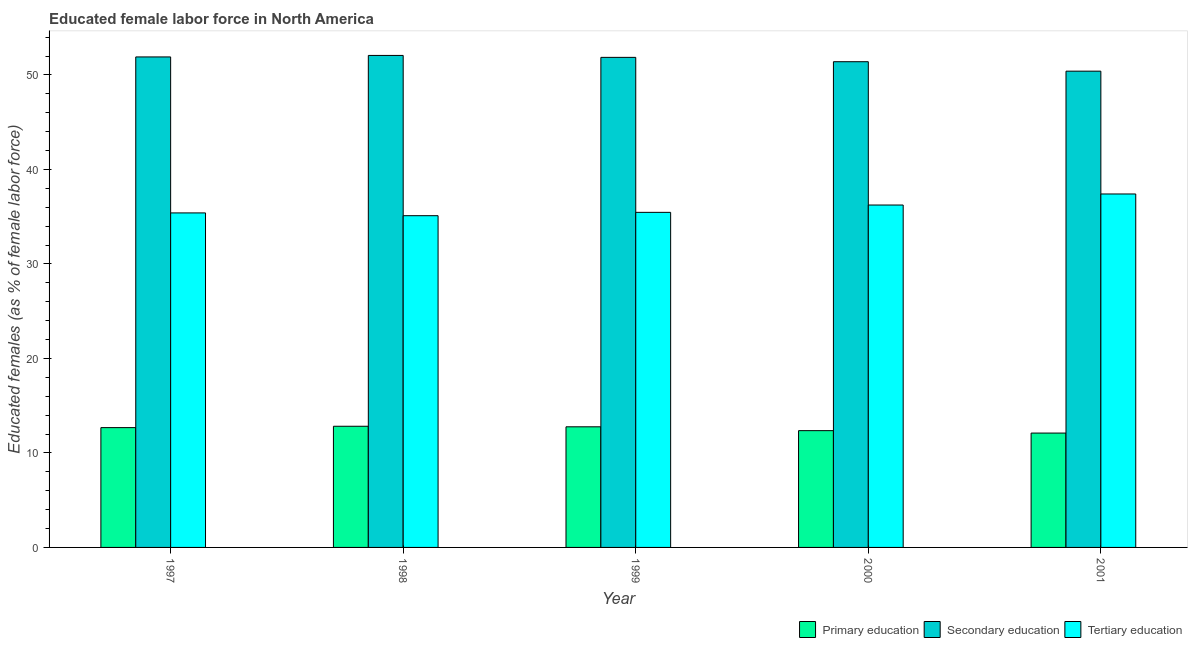Are the number of bars on each tick of the X-axis equal?
Offer a terse response. Yes. How many bars are there on the 4th tick from the left?
Your answer should be very brief. 3. What is the label of the 5th group of bars from the left?
Offer a very short reply. 2001. What is the percentage of female labor force who received primary education in 1998?
Offer a terse response. 12.82. Across all years, what is the maximum percentage of female labor force who received primary education?
Your response must be concise. 12.82. Across all years, what is the minimum percentage of female labor force who received tertiary education?
Your answer should be compact. 35.11. In which year was the percentage of female labor force who received secondary education maximum?
Your answer should be very brief. 1998. What is the total percentage of female labor force who received primary education in the graph?
Ensure brevity in your answer.  62.73. What is the difference between the percentage of female labor force who received secondary education in 1998 and that in 1999?
Your answer should be compact. 0.2. What is the difference between the percentage of female labor force who received secondary education in 1999 and the percentage of female labor force who received tertiary education in 1998?
Provide a short and direct response. -0.2. What is the average percentage of female labor force who received secondary education per year?
Offer a terse response. 51.53. What is the ratio of the percentage of female labor force who received secondary education in 1998 to that in 2000?
Your response must be concise. 1.01. Is the percentage of female labor force who received primary education in 1997 less than that in 1999?
Give a very brief answer. Yes. Is the difference between the percentage of female labor force who received primary education in 1997 and 1999 greater than the difference between the percentage of female labor force who received tertiary education in 1997 and 1999?
Your response must be concise. No. What is the difference between the highest and the second highest percentage of female labor force who received secondary education?
Offer a very short reply. 0.16. What is the difference between the highest and the lowest percentage of female labor force who received tertiary education?
Your response must be concise. 2.3. In how many years, is the percentage of female labor force who received primary education greater than the average percentage of female labor force who received primary education taken over all years?
Provide a succinct answer. 3. Is the sum of the percentage of female labor force who received secondary education in 1999 and 2001 greater than the maximum percentage of female labor force who received tertiary education across all years?
Keep it short and to the point. Yes. What does the 1st bar from the left in 1998 represents?
Your answer should be very brief. Primary education. What does the 1st bar from the right in 1999 represents?
Provide a succinct answer. Tertiary education. How many bars are there?
Offer a very short reply. 15. Are all the bars in the graph horizontal?
Your answer should be compact. No. How many years are there in the graph?
Provide a succinct answer. 5. Are the values on the major ticks of Y-axis written in scientific E-notation?
Provide a short and direct response. No. Does the graph contain any zero values?
Offer a very short reply. No. Does the graph contain grids?
Offer a terse response. No. How many legend labels are there?
Provide a short and direct response. 3. What is the title of the graph?
Ensure brevity in your answer.  Educated female labor force in North America. What is the label or title of the X-axis?
Give a very brief answer. Year. What is the label or title of the Y-axis?
Provide a succinct answer. Educated females (as % of female labor force). What is the Educated females (as % of female labor force) of Primary education in 1997?
Your answer should be compact. 12.68. What is the Educated females (as % of female labor force) in Secondary education in 1997?
Your answer should be very brief. 51.91. What is the Educated females (as % of female labor force) of Tertiary education in 1997?
Your answer should be compact. 35.4. What is the Educated females (as % of female labor force) of Primary education in 1998?
Offer a very short reply. 12.82. What is the Educated females (as % of female labor force) in Secondary education in 1998?
Your response must be concise. 52.07. What is the Educated females (as % of female labor force) in Tertiary education in 1998?
Offer a terse response. 35.11. What is the Educated females (as % of female labor force) of Primary education in 1999?
Give a very brief answer. 12.77. What is the Educated females (as % of female labor force) of Secondary education in 1999?
Provide a short and direct response. 51.86. What is the Educated females (as % of female labor force) in Tertiary education in 1999?
Make the answer very short. 35.46. What is the Educated females (as % of female labor force) in Primary education in 2000?
Your answer should be very brief. 12.36. What is the Educated females (as % of female labor force) in Secondary education in 2000?
Offer a terse response. 51.4. What is the Educated females (as % of female labor force) of Tertiary education in 2000?
Your answer should be very brief. 36.24. What is the Educated females (as % of female labor force) in Primary education in 2001?
Give a very brief answer. 12.1. What is the Educated females (as % of female labor force) in Secondary education in 2001?
Ensure brevity in your answer.  50.4. What is the Educated females (as % of female labor force) of Tertiary education in 2001?
Your answer should be very brief. 37.41. Across all years, what is the maximum Educated females (as % of female labor force) in Primary education?
Make the answer very short. 12.82. Across all years, what is the maximum Educated females (as % of female labor force) in Secondary education?
Make the answer very short. 52.07. Across all years, what is the maximum Educated females (as % of female labor force) of Tertiary education?
Ensure brevity in your answer.  37.41. Across all years, what is the minimum Educated females (as % of female labor force) of Primary education?
Keep it short and to the point. 12.1. Across all years, what is the minimum Educated females (as % of female labor force) in Secondary education?
Your response must be concise. 50.4. Across all years, what is the minimum Educated females (as % of female labor force) of Tertiary education?
Your answer should be very brief. 35.11. What is the total Educated females (as % of female labor force) in Primary education in the graph?
Your answer should be compact. 62.73. What is the total Educated females (as % of female labor force) in Secondary education in the graph?
Your answer should be very brief. 257.65. What is the total Educated females (as % of female labor force) of Tertiary education in the graph?
Your answer should be compact. 179.61. What is the difference between the Educated females (as % of female labor force) of Primary education in 1997 and that in 1998?
Make the answer very short. -0.14. What is the difference between the Educated females (as % of female labor force) in Secondary education in 1997 and that in 1998?
Your answer should be very brief. -0.16. What is the difference between the Educated females (as % of female labor force) in Tertiary education in 1997 and that in 1998?
Your response must be concise. 0.29. What is the difference between the Educated females (as % of female labor force) of Primary education in 1997 and that in 1999?
Your answer should be compact. -0.09. What is the difference between the Educated females (as % of female labor force) of Secondary education in 1997 and that in 1999?
Your response must be concise. 0.05. What is the difference between the Educated females (as % of female labor force) in Tertiary education in 1997 and that in 1999?
Provide a succinct answer. -0.06. What is the difference between the Educated females (as % of female labor force) in Primary education in 1997 and that in 2000?
Make the answer very short. 0.32. What is the difference between the Educated females (as % of female labor force) of Secondary education in 1997 and that in 2000?
Provide a succinct answer. 0.51. What is the difference between the Educated females (as % of female labor force) in Tertiary education in 1997 and that in 2000?
Offer a terse response. -0.84. What is the difference between the Educated females (as % of female labor force) in Primary education in 1997 and that in 2001?
Offer a very short reply. 0.58. What is the difference between the Educated females (as % of female labor force) of Secondary education in 1997 and that in 2001?
Offer a terse response. 1.51. What is the difference between the Educated females (as % of female labor force) in Tertiary education in 1997 and that in 2001?
Keep it short and to the point. -2. What is the difference between the Educated females (as % of female labor force) in Primary education in 1998 and that in 1999?
Provide a short and direct response. 0.06. What is the difference between the Educated females (as % of female labor force) of Secondary education in 1998 and that in 1999?
Offer a very short reply. 0.2. What is the difference between the Educated females (as % of female labor force) in Tertiary education in 1998 and that in 1999?
Provide a succinct answer. -0.35. What is the difference between the Educated females (as % of female labor force) in Primary education in 1998 and that in 2000?
Give a very brief answer. 0.46. What is the difference between the Educated females (as % of female labor force) in Secondary education in 1998 and that in 2000?
Make the answer very short. 0.66. What is the difference between the Educated females (as % of female labor force) in Tertiary education in 1998 and that in 2000?
Offer a very short reply. -1.13. What is the difference between the Educated females (as % of female labor force) of Primary education in 1998 and that in 2001?
Offer a very short reply. 0.72. What is the difference between the Educated females (as % of female labor force) in Secondary education in 1998 and that in 2001?
Your answer should be very brief. 1.67. What is the difference between the Educated females (as % of female labor force) in Tertiary education in 1998 and that in 2001?
Offer a terse response. -2.3. What is the difference between the Educated females (as % of female labor force) in Primary education in 1999 and that in 2000?
Provide a short and direct response. 0.41. What is the difference between the Educated females (as % of female labor force) in Secondary education in 1999 and that in 2000?
Offer a very short reply. 0.46. What is the difference between the Educated females (as % of female labor force) of Tertiary education in 1999 and that in 2000?
Give a very brief answer. -0.78. What is the difference between the Educated females (as % of female labor force) of Primary education in 1999 and that in 2001?
Ensure brevity in your answer.  0.66. What is the difference between the Educated females (as % of female labor force) in Secondary education in 1999 and that in 2001?
Your response must be concise. 1.46. What is the difference between the Educated females (as % of female labor force) of Tertiary education in 1999 and that in 2001?
Your answer should be compact. -1.95. What is the difference between the Educated females (as % of female labor force) of Primary education in 2000 and that in 2001?
Offer a terse response. 0.26. What is the difference between the Educated females (as % of female labor force) of Secondary education in 2000 and that in 2001?
Provide a succinct answer. 1. What is the difference between the Educated females (as % of female labor force) of Tertiary education in 2000 and that in 2001?
Offer a very short reply. -1.17. What is the difference between the Educated females (as % of female labor force) in Primary education in 1997 and the Educated females (as % of female labor force) in Secondary education in 1998?
Your answer should be very brief. -39.39. What is the difference between the Educated females (as % of female labor force) of Primary education in 1997 and the Educated females (as % of female labor force) of Tertiary education in 1998?
Offer a terse response. -22.43. What is the difference between the Educated females (as % of female labor force) in Secondary education in 1997 and the Educated females (as % of female labor force) in Tertiary education in 1998?
Offer a terse response. 16.8. What is the difference between the Educated females (as % of female labor force) of Primary education in 1997 and the Educated females (as % of female labor force) of Secondary education in 1999?
Make the answer very short. -39.18. What is the difference between the Educated females (as % of female labor force) of Primary education in 1997 and the Educated females (as % of female labor force) of Tertiary education in 1999?
Keep it short and to the point. -22.78. What is the difference between the Educated females (as % of female labor force) in Secondary education in 1997 and the Educated females (as % of female labor force) in Tertiary education in 1999?
Provide a succinct answer. 16.45. What is the difference between the Educated females (as % of female labor force) in Primary education in 1997 and the Educated females (as % of female labor force) in Secondary education in 2000?
Your answer should be very brief. -38.72. What is the difference between the Educated females (as % of female labor force) of Primary education in 1997 and the Educated females (as % of female labor force) of Tertiary education in 2000?
Offer a very short reply. -23.56. What is the difference between the Educated females (as % of female labor force) of Secondary education in 1997 and the Educated females (as % of female labor force) of Tertiary education in 2000?
Provide a short and direct response. 15.67. What is the difference between the Educated females (as % of female labor force) in Primary education in 1997 and the Educated females (as % of female labor force) in Secondary education in 2001?
Provide a short and direct response. -37.72. What is the difference between the Educated females (as % of female labor force) of Primary education in 1997 and the Educated females (as % of female labor force) of Tertiary education in 2001?
Give a very brief answer. -24.73. What is the difference between the Educated females (as % of female labor force) of Secondary education in 1997 and the Educated females (as % of female labor force) of Tertiary education in 2001?
Provide a succinct answer. 14.5. What is the difference between the Educated females (as % of female labor force) in Primary education in 1998 and the Educated females (as % of female labor force) in Secondary education in 1999?
Your answer should be very brief. -39.04. What is the difference between the Educated females (as % of female labor force) of Primary education in 1998 and the Educated females (as % of female labor force) of Tertiary education in 1999?
Your response must be concise. -22.64. What is the difference between the Educated females (as % of female labor force) of Secondary education in 1998 and the Educated females (as % of female labor force) of Tertiary education in 1999?
Offer a very short reply. 16.61. What is the difference between the Educated females (as % of female labor force) of Primary education in 1998 and the Educated females (as % of female labor force) of Secondary education in 2000?
Your answer should be very brief. -38.58. What is the difference between the Educated females (as % of female labor force) of Primary education in 1998 and the Educated females (as % of female labor force) of Tertiary education in 2000?
Offer a very short reply. -23.41. What is the difference between the Educated females (as % of female labor force) of Secondary education in 1998 and the Educated females (as % of female labor force) of Tertiary education in 2000?
Your answer should be very brief. 15.83. What is the difference between the Educated females (as % of female labor force) of Primary education in 1998 and the Educated females (as % of female labor force) of Secondary education in 2001?
Offer a very short reply. -37.58. What is the difference between the Educated females (as % of female labor force) in Primary education in 1998 and the Educated females (as % of female labor force) in Tertiary education in 2001?
Make the answer very short. -24.58. What is the difference between the Educated females (as % of female labor force) in Secondary education in 1998 and the Educated females (as % of female labor force) in Tertiary education in 2001?
Offer a very short reply. 14.66. What is the difference between the Educated females (as % of female labor force) in Primary education in 1999 and the Educated females (as % of female labor force) in Secondary education in 2000?
Your response must be concise. -38.64. What is the difference between the Educated females (as % of female labor force) of Primary education in 1999 and the Educated females (as % of female labor force) of Tertiary education in 2000?
Offer a terse response. -23.47. What is the difference between the Educated females (as % of female labor force) of Secondary education in 1999 and the Educated females (as % of female labor force) of Tertiary education in 2000?
Provide a short and direct response. 15.63. What is the difference between the Educated females (as % of female labor force) of Primary education in 1999 and the Educated females (as % of female labor force) of Secondary education in 2001?
Ensure brevity in your answer.  -37.64. What is the difference between the Educated females (as % of female labor force) of Primary education in 1999 and the Educated females (as % of female labor force) of Tertiary education in 2001?
Provide a succinct answer. -24.64. What is the difference between the Educated females (as % of female labor force) of Secondary education in 1999 and the Educated females (as % of female labor force) of Tertiary education in 2001?
Offer a very short reply. 14.46. What is the difference between the Educated females (as % of female labor force) in Primary education in 2000 and the Educated females (as % of female labor force) in Secondary education in 2001?
Provide a succinct answer. -38.04. What is the difference between the Educated females (as % of female labor force) in Primary education in 2000 and the Educated females (as % of female labor force) in Tertiary education in 2001?
Give a very brief answer. -25.05. What is the difference between the Educated females (as % of female labor force) of Secondary education in 2000 and the Educated females (as % of female labor force) of Tertiary education in 2001?
Give a very brief answer. 14. What is the average Educated females (as % of female labor force) in Primary education per year?
Provide a short and direct response. 12.55. What is the average Educated females (as % of female labor force) of Secondary education per year?
Offer a terse response. 51.53. What is the average Educated females (as % of female labor force) in Tertiary education per year?
Offer a terse response. 35.92. In the year 1997, what is the difference between the Educated females (as % of female labor force) in Primary education and Educated females (as % of female labor force) in Secondary education?
Give a very brief answer. -39.23. In the year 1997, what is the difference between the Educated females (as % of female labor force) in Primary education and Educated females (as % of female labor force) in Tertiary education?
Keep it short and to the point. -22.72. In the year 1997, what is the difference between the Educated females (as % of female labor force) of Secondary education and Educated females (as % of female labor force) of Tertiary education?
Provide a succinct answer. 16.51. In the year 1998, what is the difference between the Educated females (as % of female labor force) in Primary education and Educated females (as % of female labor force) in Secondary education?
Your response must be concise. -39.24. In the year 1998, what is the difference between the Educated females (as % of female labor force) in Primary education and Educated females (as % of female labor force) in Tertiary education?
Offer a terse response. -22.28. In the year 1998, what is the difference between the Educated females (as % of female labor force) in Secondary education and Educated females (as % of female labor force) in Tertiary education?
Make the answer very short. 16.96. In the year 1999, what is the difference between the Educated females (as % of female labor force) in Primary education and Educated females (as % of female labor force) in Secondary education?
Offer a terse response. -39.1. In the year 1999, what is the difference between the Educated females (as % of female labor force) in Primary education and Educated females (as % of female labor force) in Tertiary education?
Your answer should be very brief. -22.69. In the year 1999, what is the difference between the Educated females (as % of female labor force) in Secondary education and Educated females (as % of female labor force) in Tertiary education?
Offer a very short reply. 16.4. In the year 2000, what is the difference between the Educated females (as % of female labor force) in Primary education and Educated females (as % of female labor force) in Secondary education?
Your answer should be compact. -39.05. In the year 2000, what is the difference between the Educated females (as % of female labor force) in Primary education and Educated females (as % of female labor force) in Tertiary education?
Your response must be concise. -23.88. In the year 2000, what is the difference between the Educated females (as % of female labor force) of Secondary education and Educated females (as % of female labor force) of Tertiary education?
Make the answer very short. 15.17. In the year 2001, what is the difference between the Educated females (as % of female labor force) in Primary education and Educated females (as % of female labor force) in Secondary education?
Your response must be concise. -38.3. In the year 2001, what is the difference between the Educated females (as % of female labor force) in Primary education and Educated females (as % of female labor force) in Tertiary education?
Offer a terse response. -25.3. In the year 2001, what is the difference between the Educated females (as % of female labor force) in Secondary education and Educated females (as % of female labor force) in Tertiary education?
Provide a succinct answer. 13. What is the ratio of the Educated females (as % of female labor force) of Primary education in 1997 to that in 1998?
Ensure brevity in your answer.  0.99. What is the ratio of the Educated females (as % of female labor force) of Tertiary education in 1997 to that in 1998?
Provide a succinct answer. 1.01. What is the ratio of the Educated females (as % of female labor force) of Primary education in 1997 to that in 1999?
Keep it short and to the point. 0.99. What is the ratio of the Educated females (as % of female labor force) in Secondary education in 1997 to that in 1999?
Your answer should be compact. 1. What is the ratio of the Educated females (as % of female labor force) in Tertiary education in 1997 to that in 1999?
Provide a short and direct response. 1. What is the ratio of the Educated females (as % of female labor force) in Primary education in 1997 to that in 2000?
Your answer should be very brief. 1.03. What is the ratio of the Educated females (as % of female labor force) of Secondary education in 1997 to that in 2000?
Provide a short and direct response. 1.01. What is the ratio of the Educated females (as % of female labor force) of Tertiary education in 1997 to that in 2000?
Provide a succinct answer. 0.98. What is the ratio of the Educated females (as % of female labor force) of Primary education in 1997 to that in 2001?
Ensure brevity in your answer.  1.05. What is the ratio of the Educated females (as % of female labor force) in Secondary education in 1997 to that in 2001?
Offer a terse response. 1.03. What is the ratio of the Educated females (as % of female labor force) in Tertiary education in 1997 to that in 2001?
Provide a succinct answer. 0.95. What is the ratio of the Educated females (as % of female labor force) of Secondary education in 1998 to that in 1999?
Your response must be concise. 1. What is the ratio of the Educated females (as % of female labor force) of Tertiary education in 1998 to that in 1999?
Your answer should be compact. 0.99. What is the ratio of the Educated females (as % of female labor force) in Primary education in 1998 to that in 2000?
Offer a very short reply. 1.04. What is the ratio of the Educated females (as % of female labor force) of Secondary education in 1998 to that in 2000?
Provide a succinct answer. 1.01. What is the ratio of the Educated females (as % of female labor force) of Tertiary education in 1998 to that in 2000?
Make the answer very short. 0.97. What is the ratio of the Educated females (as % of female labor force) of Primary education in 1998 to that in 2001?
Offer a terse response. 1.06. What is the ratio of the Educated females (as % of female labor force) in Secondary education in 1998 to that in 2001?
Offer a very short reply. 1.03. What is the ratio of the Educated females (as % of female labor force) in Tertiary education in 1998 to that in 2001?
Offer a terse response. 0.94. What is the ratio of the Educated females (as % of female labor force) in Primary education in 1999 to that in 2000?
Provide a succinct answer. 1.03. What is the ratio of the Educated females (as % of female labor force) of Secondary education in 1999 to that in 2000?
Keep it short and to the point. 1.01. What is the ratio of the Educated females (as % of female labor force) of Tertiary education in 1999 to that in 2000?
Your response must be concise. 0.98. What is the ratio of the Educated females (as % of female labor force) in Primary education in 1999 to that in 2001?
Provide a short and direct response. 1.05. What is the ratio of the Educated females (as % of female labor force) of Secondary education in 1999 to that in 2001?
Offer a very short reply. 1.03. What is the ratio of the Educated females (as % of female labor force) of Tertiary education in 1999 to that in 2001?
Keep it short and to the point. 0.95. What is the ratio of the Educated females (as % of female labor force) in Primary education in 2000 to that in 2001?
Give a very brief answer. 1.02. What is the ratio of the Educated females (as % of female labor force) in Secondary education in 2000 to that in 2001?
Offer a very short reply. 1.02. What is the ratio of the Educated females (as % of female labor force) of Tertiary education in 2000 to that in 2001?
Provide a succinct answer. 0.97. What is the difference between the highest and the second highest Educated females (as % of female labor force) of Primary education?
Keep it short and to the point. 0.06. What is the difference between the highest and the second highest Educated females (as % of female labor force) in Secondary education?
Your answer should be very brief. 0.16. What is the difference between the highest and the second highest Educated females (as % of female labor force) of Tertiary education?
Provide a succinct answer. 1.17. What is the difference between the highest and the lowest Educated females (as % of female labor force) in Primary education?
Your answer should be very brief. 0.72. What is the difference between the highest and the lowest Educated females (as % of female labor force) in Secondary education?
Your answer should be very brief. 1.67. What is the difference between the highest and the lowest Educated females (as % of female labor force) in Tertiary education?
Your answer should be compact. 2.3. 